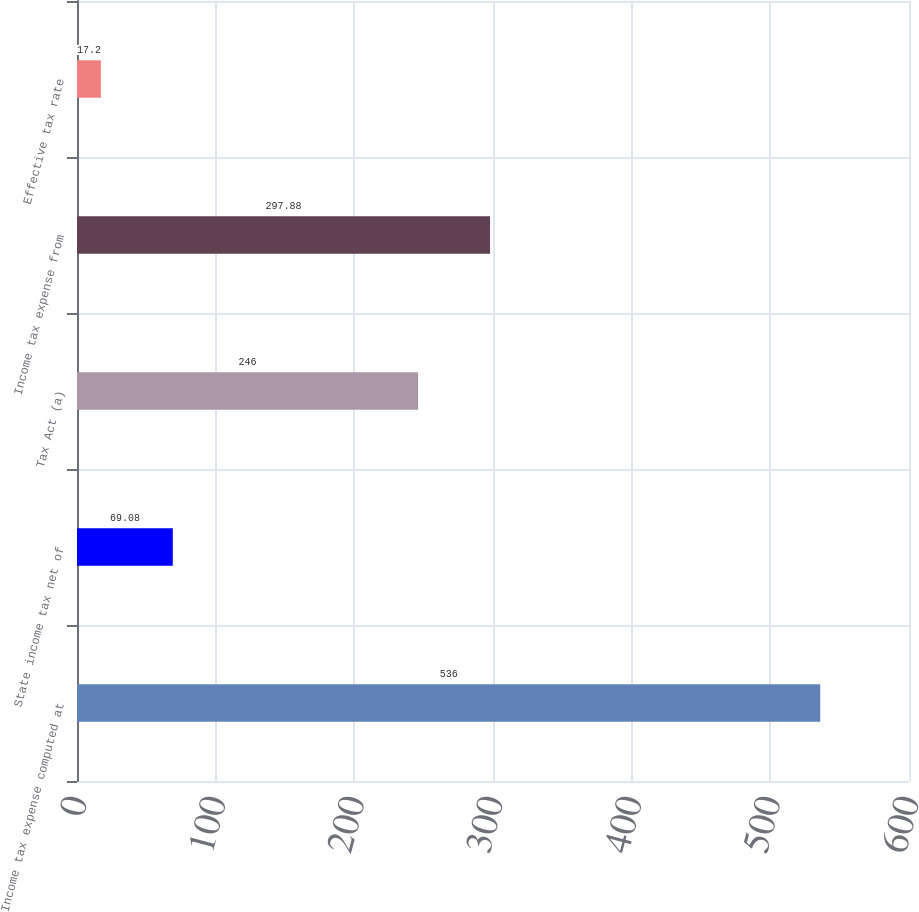Convert chart. <chart><loc_0><loc_0><loc_500><loc_500><bar_chart><fcel>Income tax expense computed at<fcel>State income tax net of<fcel>Tax Act (a)<fcel>Income tax expense from<fcel>Effective tax rate<nl><fcel>536<fcel>69.08<fcel>246<fcel>297.88<fcel>17.2<nl></chart> 